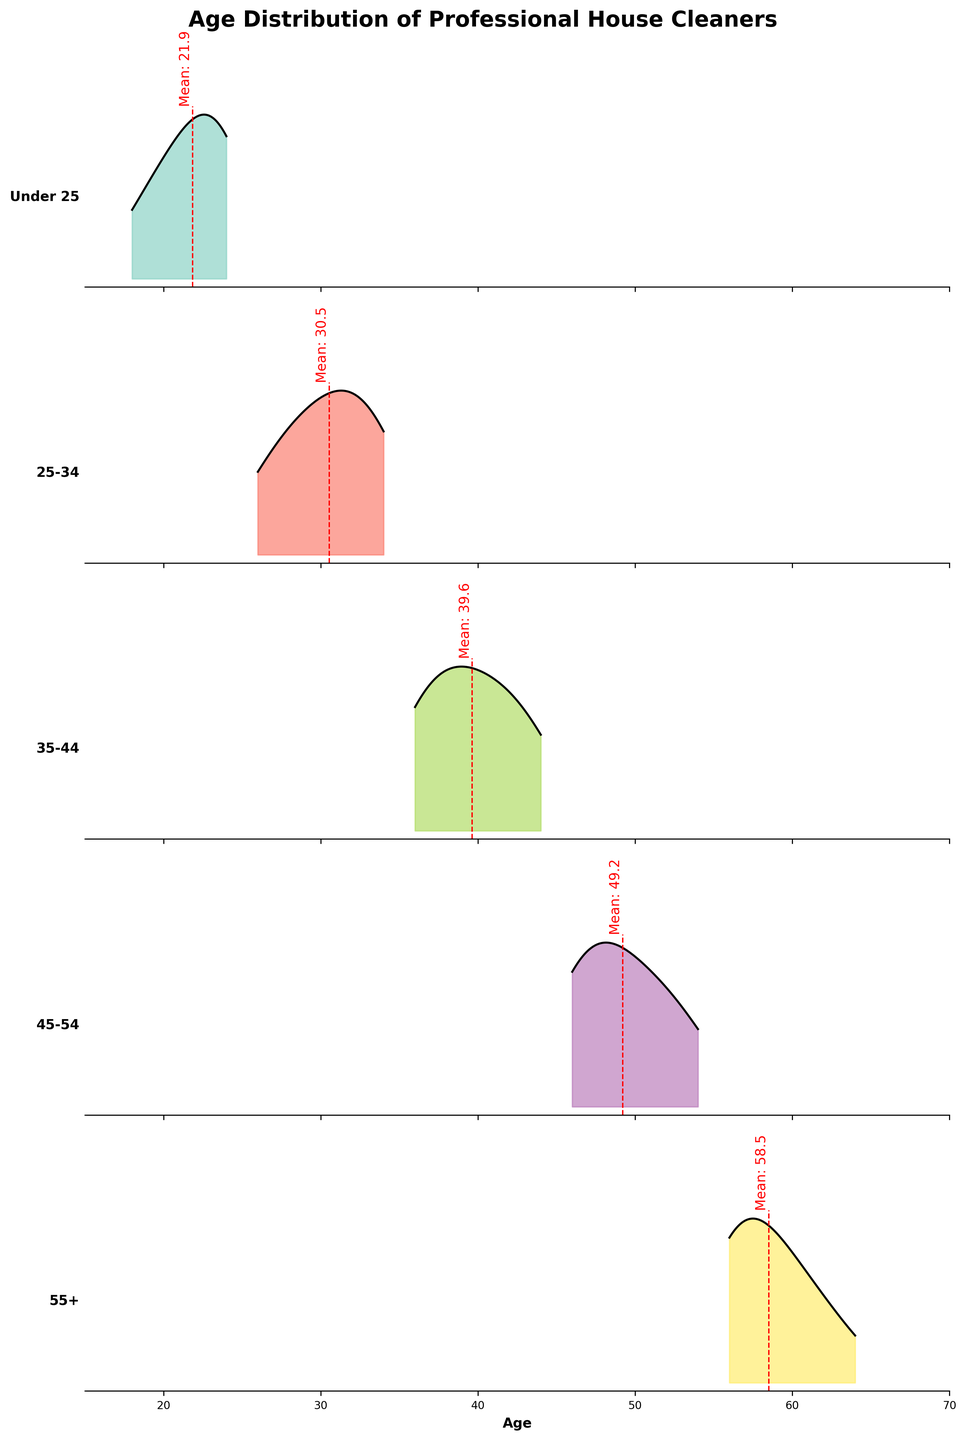What's the title of the figure? The title of the plot is displayed at the top of the figure in bold. Here, it reads "Age Distribution of Professional House Cleaners".
Answer: Age Distribution of Professional House Cleaners What is shown on the x-axis of the figure? The x-axis of the figure, which is located at the bottom of all subplots, is labeled with "Age" and spans from ages 15 to 70.
Answer: Age Which age category has the highest peak in the density plot? To determine the highest peak, you need to look at the subplot with the tallest filled area under the curve. This is the category "25-34".
Answer: 25-34 What color represents the age category "55+"? The colors for each category are distinct and can be identified by looking at the subplots. The age category "55+" is represented by a color from the Set3 colormap.
Answer: Light orange (not exact due to colormap variation) What is the approximate mean age for the "35-44" age category? The mean age is indicated by a vertical red dashed line in each subplot with a corresponding annotation. For the "35-44" category, the mean age is approximately 38.
Answer: 38 How does the density plot for "Under 25" compare to that of "45-54"? Comparing the two subplots visually, you can see that "Under 25" has a generally higher peak and a more spread-out distribution, while "45-54" has a lower peak and a narrower distribution.
Answer: "Under 25" has a higher and wider distribution compared to "45-54" Which age category has the least extensive spread in ages? The age category with the narrowest distribution will have the smallest range between the minimum and maximum ages, as seen in the density plot. This appears to be "55+".
Answer: 55+ In which age category does 30 fall? To determine this, you can look at the x-axis and see which subplot contains the age of 30. This falls within the "25-34" category.
Answer: 25-34 What is the approximate range of ages for the "Under 25" category? The range of ages can be determined by looking at the x-axis values that span the density plot for the category "Under 25". It ranges approximately from 18 to 24.
Answer: 18-24 